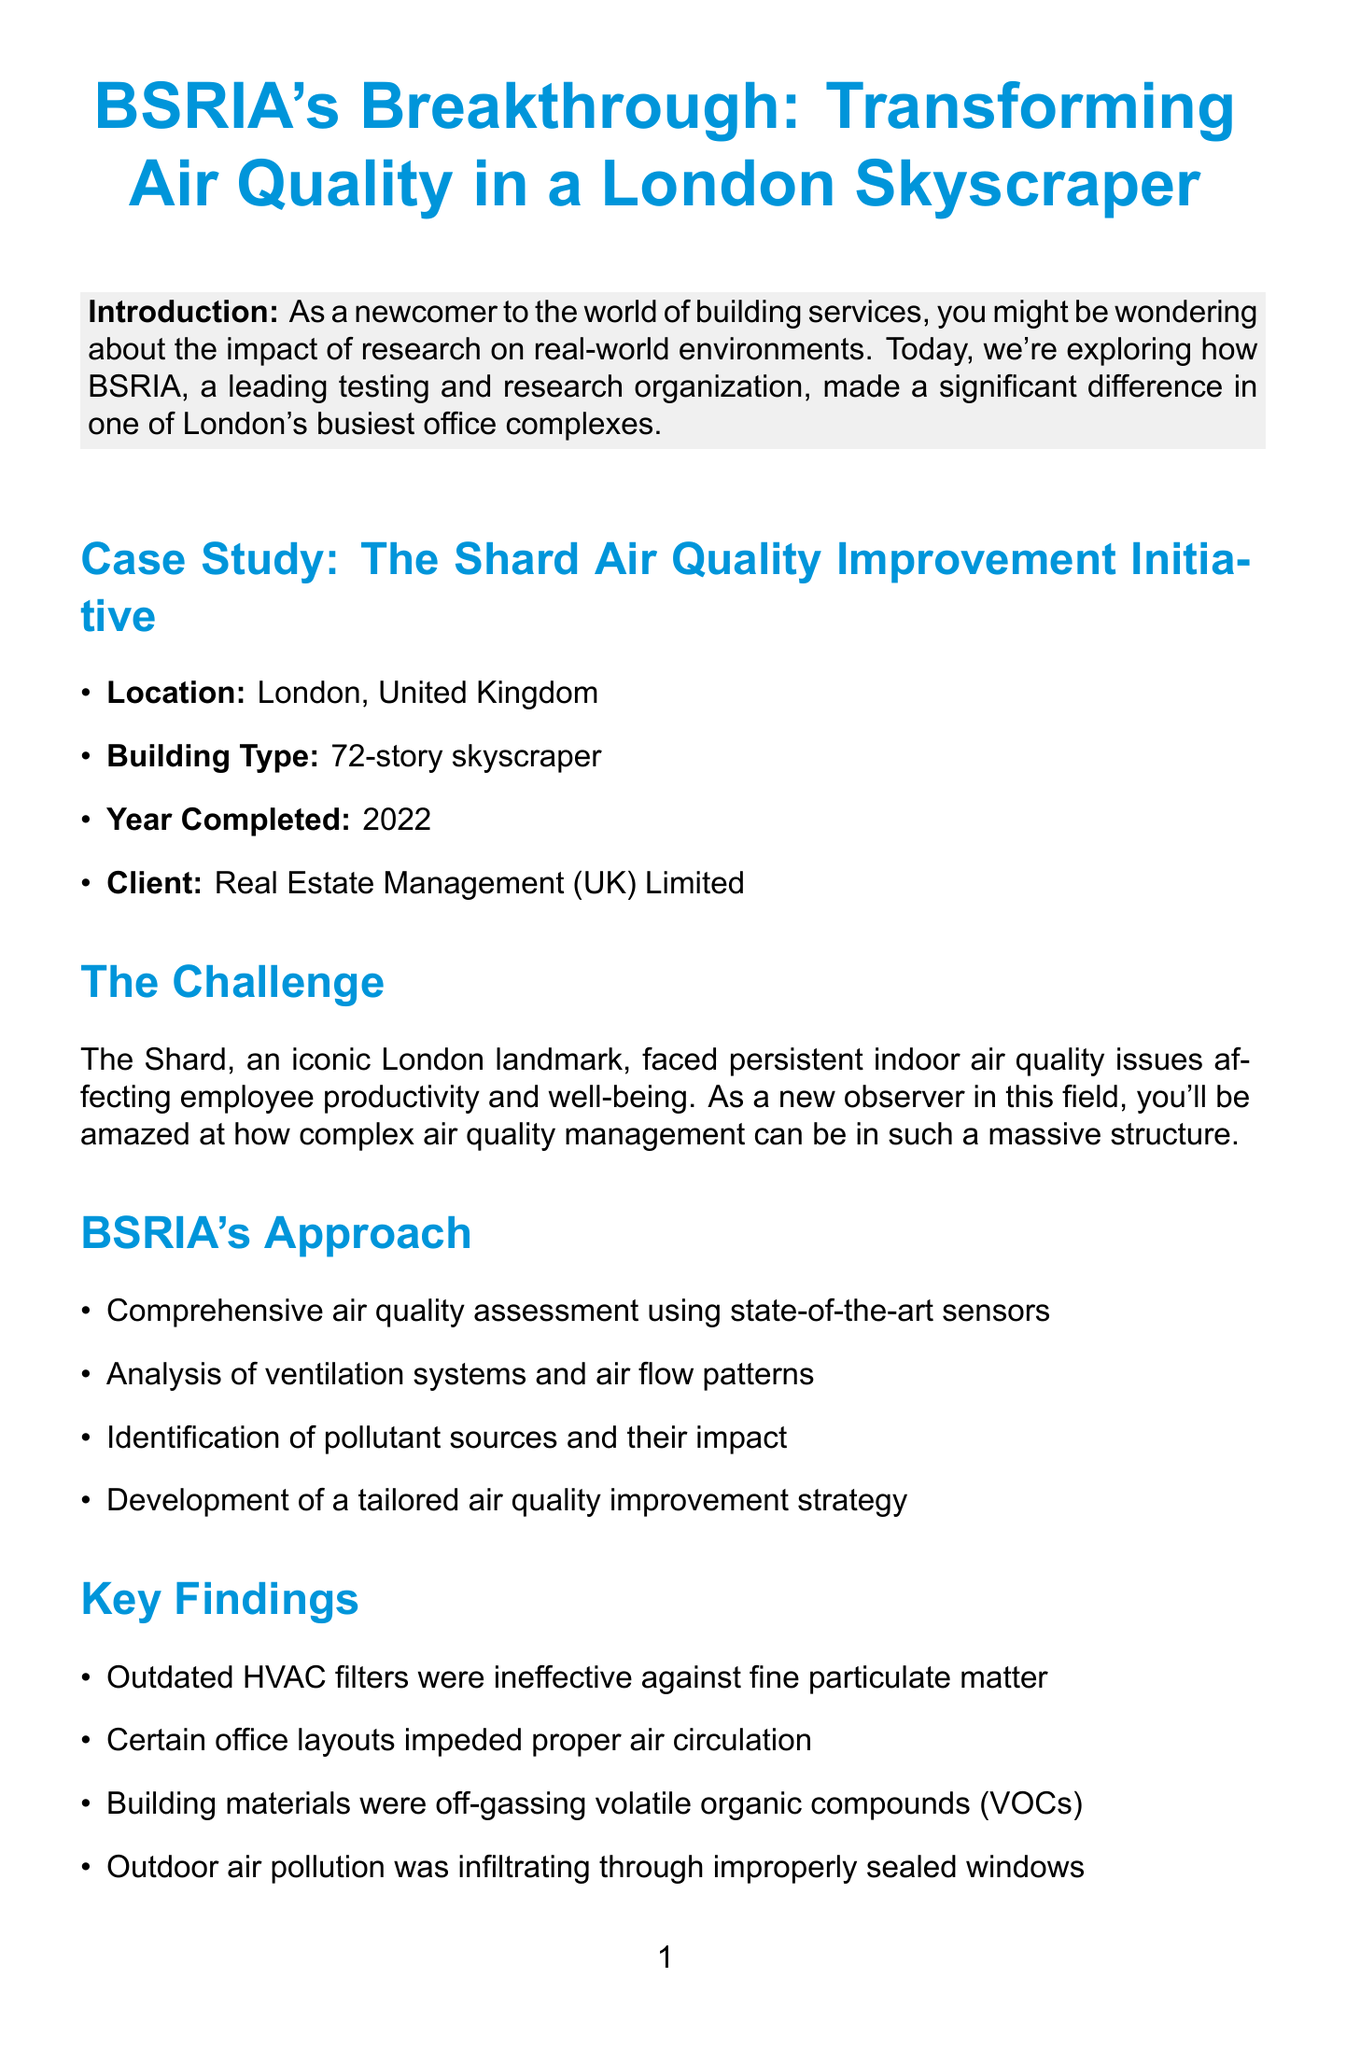What is the building type of The Shard? The document specifies The Shard as a "72-story skyscraper."
Answer: 72-story skyscraper Who was the client for the project? The client for the initiative to improve air quality at The Shard was "Real Estate Management (UK) Limited."
Answer: Real Estate Management (UK) Limited What year was the air quality improvement project completed? The completion year of the project is mentioned as "2022."
Answer: 2022 What percentage reduction in indoor air pollutants was achieved? The results section states there was a "62% reduction in indoor air pollutants."
Answer: 62% What was one major finding regarding HVAC filters? It was found that "outdated HVAC filters were ineffective against fine particulate matter."
Answer: ineffective against fine particulate matter What improvement was made regarding air flow in office spaces? The solution included the "redesign of office spaces to optimize air flow."
Answer: redesign of office spaces What health benefit was reported among occupants? The case study mentions a "27% reduction in reported respiratory symptoms among occupants."
Answer: 27% reduction in reported respiratory symptoms What is the contact email for more information? The document provides an email address for inquiries as "airquality@bsria.co.uk."
Answer: airquality@bsria.co.uk What did Emma Thompson say about BSRIA's contribution? Emma Thompson remarks that BSRIA's research has "transformed our working environment."
Answer: transformed our working environment 